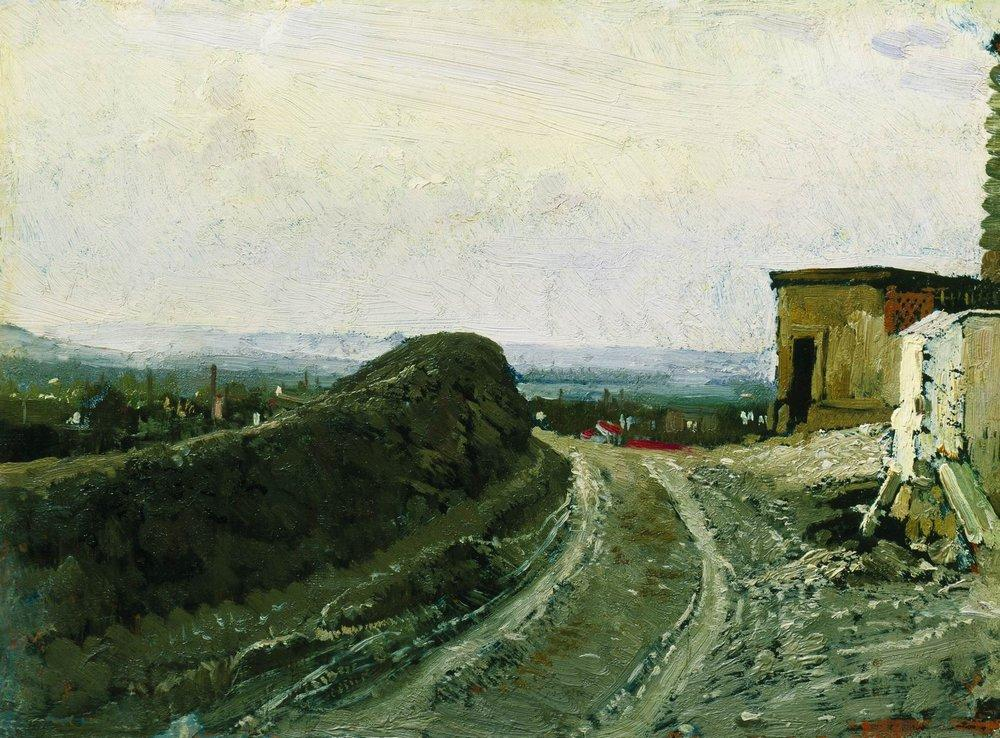Describe the following image. The image depicts an oil painting in an impressionist style, showcasing a vivid rural landscape. The painting captures a winding dirt road that draws the viewer's attention through the canvas, surrounded by lush, vibrant greenery and a quaint building with a striking red flag on the right. The impressionist technique is evident in the loose, expressive brushstrokes, prioritizing the impression of light and color over detail. The palette consists mainly of earthy greens and browns, with the red adding a dynamic contrast that catches the eye. In the distance, a hazy townscape adds depth and suggests the broad expanse of the landscape. This painting not only portrays a serene, idyllic countryside but also evokes a sense of tranquility and timeless beauty typical of the impressionist movement, which aimed to capture the fleeting moments of light in the natural world. 